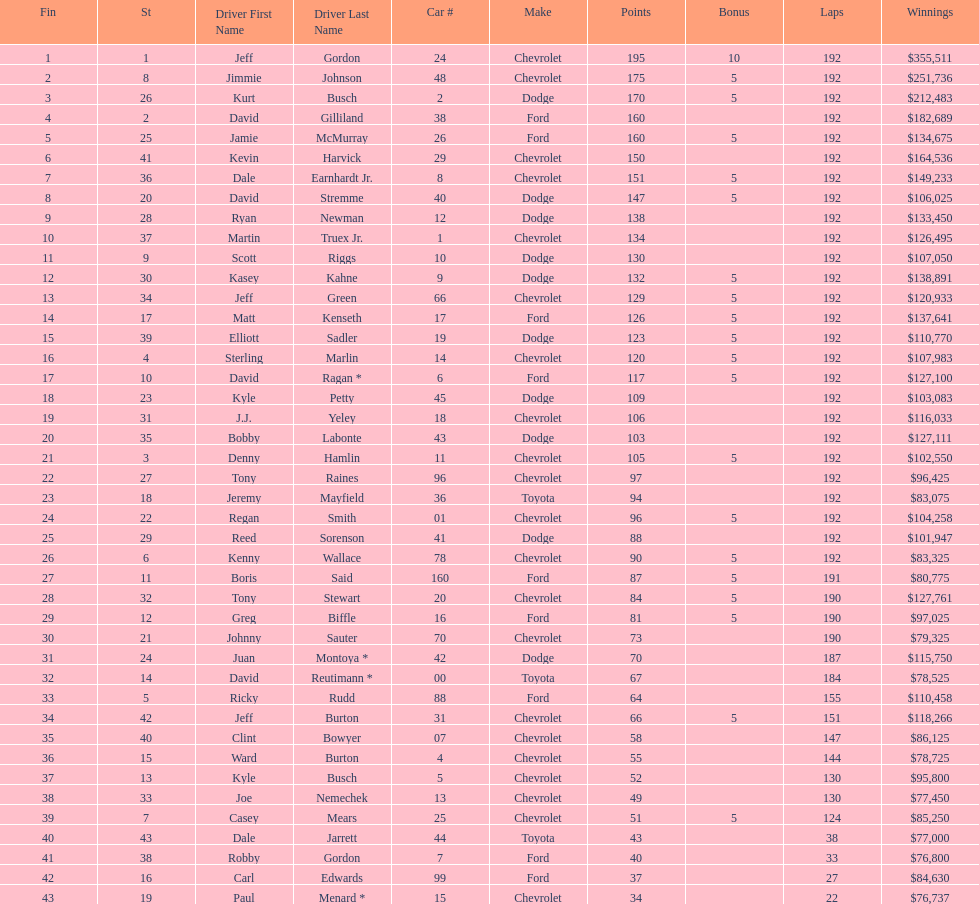How many drivers placed below tony stewart? 15. Could you help me parse every detail presented in this table? {'header': ['Fin', 'St', 'Driver First Name', 'Driver Last Name', 'Car #', 'Make', 'Points', 'Bonus', 'Laps', 'Winnings'], 'rows': [['1', '1', 'Jeff', 'Gordon', '24', 'Chevrolet', '195', '10', '192', '$355,511'], ['2', '8', 'Jimmie', 'Johnson', '48', 'Chevrolet', '175', '5', '192', '$251,736'], ['3', '26', 'Kurt', 'Busch', '2', 'Dodge', '170', '5', '192', '$212,483'], ['4', '2', 'David', 'Gilliland', '38', 'Ford', '160', '', '192', '$182,689'], ['5', '25', 'Jamie', 'McMurray', '26', 'Ford', '160', '5', '192', '$134,675'], ['6', '41', 'Kevin', 'Harvick', '29', 'Chevrolet', '150', '', '192', '$164,536'], ['7', '36', 'Dale', 'Earnhardt Jr.', '8', 'Chevrolet', '151', '5', '192', '$149,233'], ['8', '20', 'David', 'Stremme', '40', 'Dodge', '147', '5', '192', '$106,025'], ['9', '28', 'Ryan', 'Newman', '12', 'Dodge', '138', '', '192', '$133,450'], ['10', '37', 'Martin', 'Truex Jr.', '1', 'Chevrolet', '134', '', '192', '$126,495'], ['11', '9', 'Scott', 'Riggs', '10', 'Dodge', '130', '', '192', '$107,050'], ['12', '30', 'Kasey', 'Kahne', '9', 'Dodge', '132', '5', '192', '$138,891'], ['13', '34', 'Jeff', 'Green', '66', 'Chevrolet', '129', '5', '192', '$120,933'], ['14', '17', 'Matt', 'Kenseth', '17', 'Ford', '126', '5', '192', '$137,641'], ['15', '39', 'Elliott', 'Sadler', '19', 'Dodge', '123', '5', '192', '$110,770'], ['16', '4', 'Sterling', 'Marlin', '14', 'Chevrolet', '120', '5', '192', '$107,983'], ['17', '10', 'David', 'Ragan *', '6', 'Ford', '117', '5', '192', '$127,100'], ['18', '23', 'Kyle', 'Petty', '45', 'Dodge', '109', '', '192', '$103,083'], ['19', '31', 'J.J.', 'Yeley', '18', 'Chevrolet', '106', '', '192', '$116,033'], ['20', '35', 'Bobby', 'Labonte', '43', 'Dodge', '103', '', '192', '$127,111'], ['21', '3', 'Denny', 'Hamlin', '11', 'Chevrolet', '105', '5', '192', '$102,550'], ['22', '27', 'Tony', 'Raines', '96', 'Chevrolet', '97', '', '192', '$96,425'], ['23', '18', 'Jeremy', 'Mayfield', '36', 'Toyota', '94', '', '192', '$83,075'], ['24', '22', 'Regan', 'Smith', '01', 'Chevrolet', '96', '5', '192', '$104,258'], ['25', '29', 'Reed', 'Sorenson', '41', 'Dodge', '88', '', '192', '$101,947'], ['26', '6', 'Kenny', 'Wallace', '78', 'Chevrolet', '90', '5', '192', '$83,325'], ['27', '11', 'Boris', 'Said', '160', 'Ford', '87', '5', '191', '$80,775'], ['28', '32', 'Tony', 'Stewart', '20', 'Chevrolet', '84', '5', '190', '$127,761'], ['29', '12', 'Greg', 'Biffle', '16', 'Ford', '81', '5', '190', '$97,025'], ['30', '21', 'Johnny', 'Sauter', '70', 'Chevrolet', '73', '', '190', '$79,325'], ['31', '24', 'Juan', 'Montoya *', '42', 'Dodge', '70', '', '187', '$115,750'], ['32', '14', 'David', 'Reutimann *', '00', 'Toyota', '67', '', '184', '$78,525'], ['33', '5', 'Ricky', 'Rudd', '88', 'Ford', '64', '', '155', '$110,458'], ['34', '42', 'Jeff', 'Burton', '31', 'Chevrolet', '66', '5', '151', '$118,266'], ['35', '40', 'Clint', 'Bowyer', '07', 'Chevrolet', '58', '', '147', '$86,125'], ['36', '15', 'Ward', 'Burton', '4', 'Chevrolet', '55', '', '144', '$78,725'], ['37', '13', 'Kyle', 'Busch', '5', 'Chevrolet', '52', '', '130', '$95,800'], ['38', '33', 'Joe', 'Nemechek', '13', 'Chevrolet', '49', '', '130', '$77,450'], ['39', '7', 'Casey', 'Mears', '25', 'Chevrolet', '51', '5', '124', '$85,250'], ['40', '43', 'Dale', 'Jarrett', '44', 'Toyota', '43', '', '38', '$77,000'], ['41', '38', 'Robby', 'Gordon', '7', 'Ford', '40', '', '33', '$76,800'], ['42', '16', 'Carl', 'Edwards', '99', 'Ford', '37', '', '27', '$84,630'], ['43', '19', 'Paul', 'Menard *', '15', 'Chevrolet', '34', '', '22', '$76,737']]} 